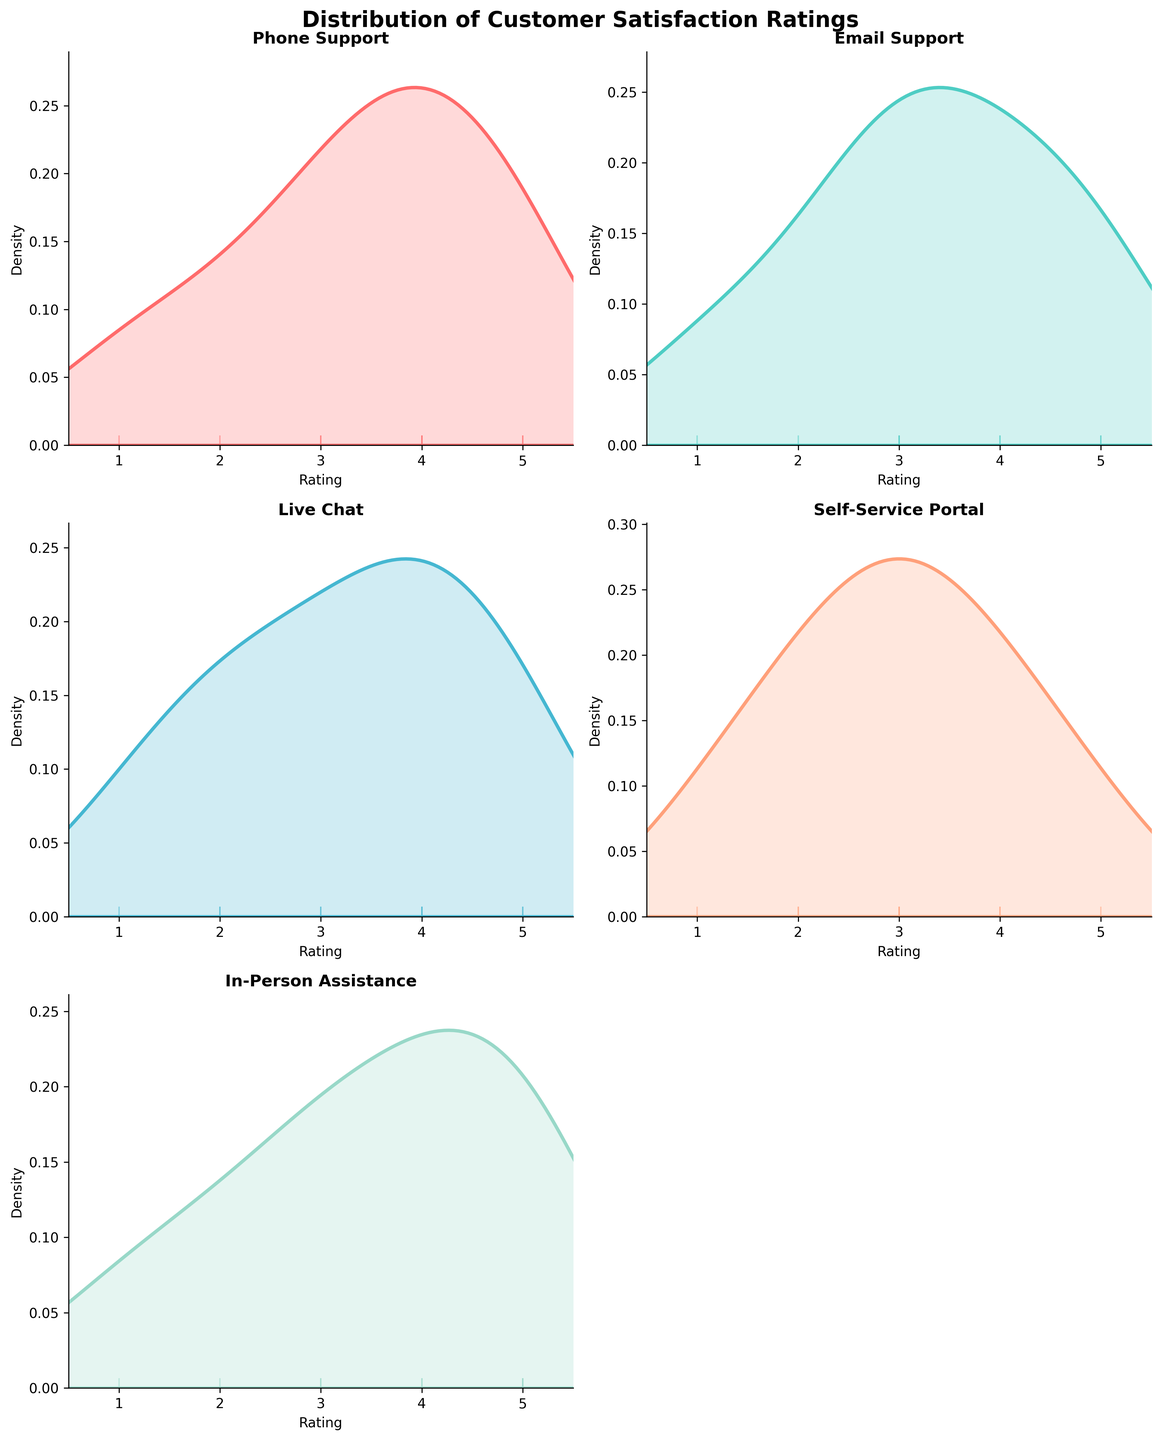What is the title of the figure? The title is given at the top of the figure. It is styled with a bigger font size and bold formatting, making it distinct.
Answer: 'Distribution of Customer Satisfaction Ratings' How many service categories are being compared in the figure? The figure shows subplots, each representing a different service category. By counting the subplots with titles, we can determine the number of categories.
Answer: 5 What service category distribution has a mode at rating 3? The mode can be identified by the peak of the density plot. Comparing the plots, the distributions most frequently peaking around rating 3 are observed.
Answer: Self-Service Portal Which service category shows the least variation in customer satisfaction ratings? The category with the narrowest spread around the peak of the density plot shows the least variation in ratings. Comparing the density plot spreads will help in identifying this.
Answer: Phone Support How does the density plot for 'Email Support' compare to 'Live Chat'? Compare the peaks and spreads of the density plots for these two categories. We need to check if their peaks and distributions are similar or different.
Answer: 'Email Support' and 'Live Chat' both show peaks around 4, but 'Live Chat' has a more spread-out distribution Which service category has the highest density peak? The height of the peak in each density plot represents the highest density. Comparing the peaks across all subplots determines this.
Answer: Email Support In terms of rating distribution, how do 'In-Person Assistance' and 'Phone Support' differ? Compare the shape, peaks, and spread of the density plots for these two categories to see how their distributions differ.
Answer: 'In-Person Assistance' shows multiple peaks indicating varied satisfaction, whereas 'Phone Support' has a clear peak around rating 4 Is there a visible trend regarding customer satisfaction across the service categories? Look at where the peaks are located on the x-axis for each plot. Most peaks around higher ratings indicate higher overall customer satisfaction.
Answer: Most categories peak around rating 4, indicating a general satisfaction trend near good ratings Which service category has a bimodal distribution? A bimodal distribution will have two distinct peaks in the density plot. Look for plots where this characteristic is present.
Answer: In-Person Assistance 